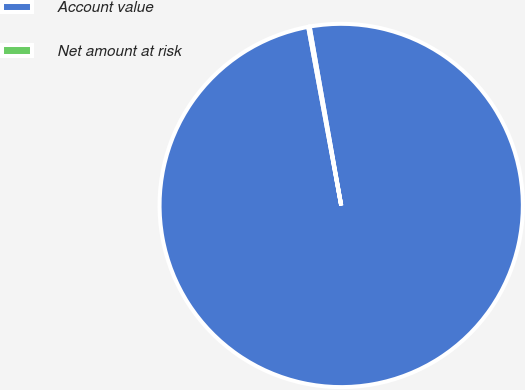Convert chart. <chart><loc_0><loc_0><loc_500><loc_500><pie_chart><fcel>Account value<fcel>Net amount at risk<nl><fcel>99.87%<fcel>0.13%<nl></chart> 